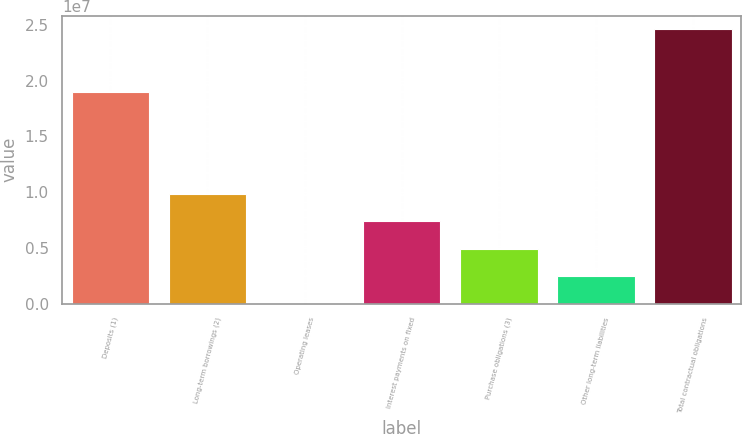Convert chart to OTSL. <chart><loc_0><loc_0><loc_500><loc_500><bar_chart><fcel>Deposits (1)<fcel>Long-term borrowings (2)<fcel>Operating leases<fcel>Interest payments on fixed<fcel>Purchase obligations (3)<fcel>Other long-term liabilities<fcel>Total contractual obligations<nl><fcel>1.89452e+07<fcel>9.84233e+06<fcel>5843<fcel>7.38321e+06<fcel>4.92409e+06<fcel>2.46497e+06<fcel>2.45971e+07<nl></chart> 